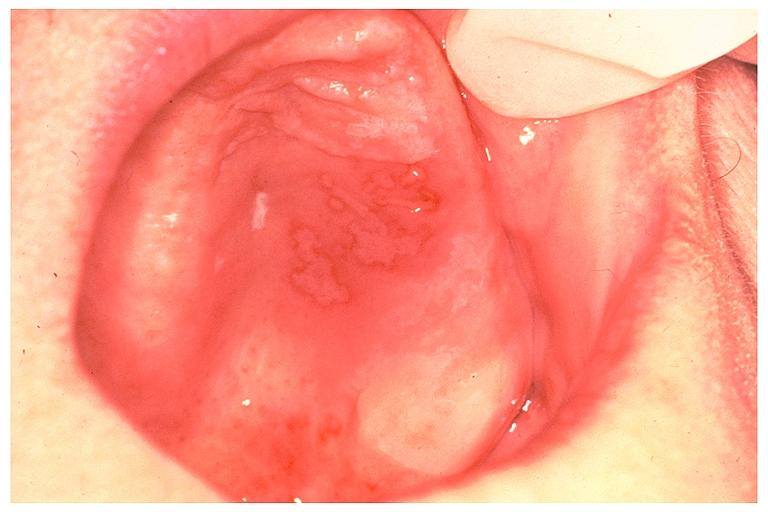what does this image show?
Answer the question using a single word or phrase. Recurrent intraoral herpes simplex 